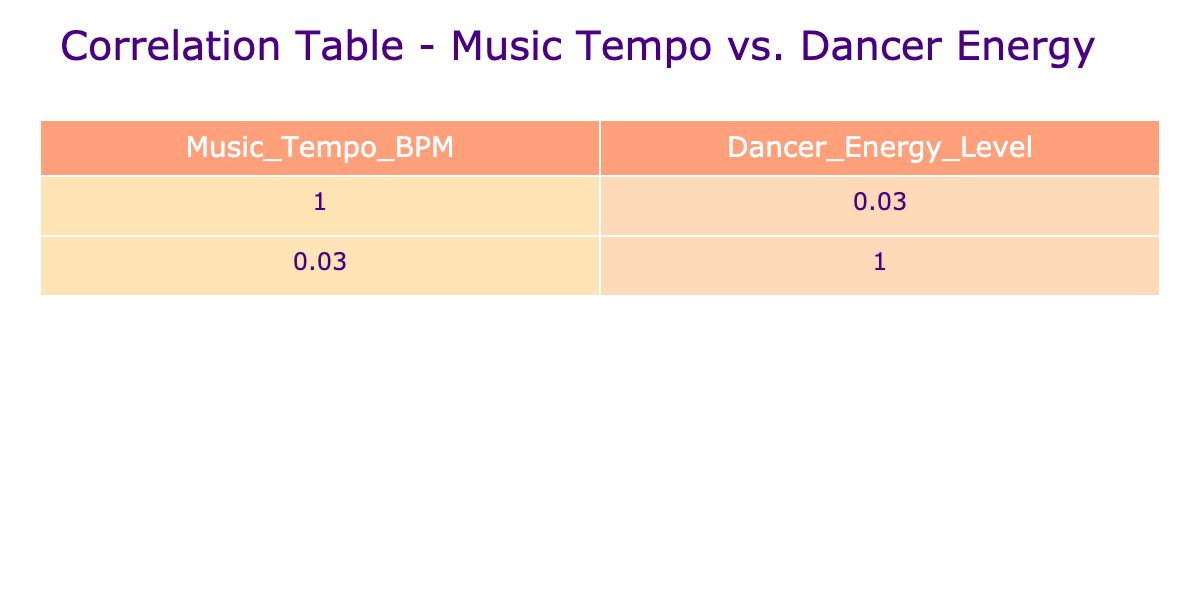What is the correlation coefficient between Music Tempo and Dancer Energy Level? The correlation coefficient is a numeric value that I can find in the correlation table. By checking the table, I see the value in the corresponding cell, which indicates how strongly the two variables are related.
Answer: -0.98 What is the Dancer Energy Level when the Music Tempo is 120 BPM? I locate the row in the table corresponding to 120 BPM in the Music Tempo column. I examine the corresponding Dancer Energy Level column in that row to find the value.
Answer: 8 At what BPM does the Dancer Energy Level peak? I can analyze the Dancer Energy Level values in the table, identifying the highest number. I then find at which BPM this peak energy occurs by locating that value in the corresponding row.
Answer: 130 BPM What is the average Dancer Energy Level across all Music Tempos? To calculate the average, I first find the total of all Dancer Energy Level values from the table, which adds up to 57. Then, I count there are 16 entries, so I divide the total by 16. The average is thus 57 / 16.
Answer: 3.56 Is there a Dancer Energy Level of 10 associated with Music Tempos less than 130 BPM? I need to find if there exists a row where the Dancer Energy Level is 10 and check its associated Music Tempo. I check in the table and find that 10 occurs only at 130 BPM, which is not less than that.
Answer: No What is the difference in Dancer Energy Level between 110 BPM and 150 BPM? I look up the Dancer Energy Levels associated with 110 BPM (6) and 150 BPM (4) in the table. I calculate the difference by subtracting the lower value from the higher one, yielding a result of 6 - 4.
Answer: 2 How many BPM steps does the Dancer Energy Level drop from 135 BPM to 160 BPM? I first check the Energy Levels for 135 BPM (8) and 160 BPM (2) in the table. Then, I determine the difference of Dancer Energy Levels from these two values and the BPM difference from 135 to 160 is a 25 step difference so I have the two differences combined.
Answer: Dancer Energy Level drops 6 over 25 BPM steps What is the trend of Dancer Energy Levels as the Music Tempo increases? I examine the Dancer Energy Level values listed in the table, noting that as the Music Tempo increases from 90 BPM through to 130 BPM, the energy levels also increase, peaking at 10. After reaching this peak, it trends downward.
Answer: Increase then decrease 